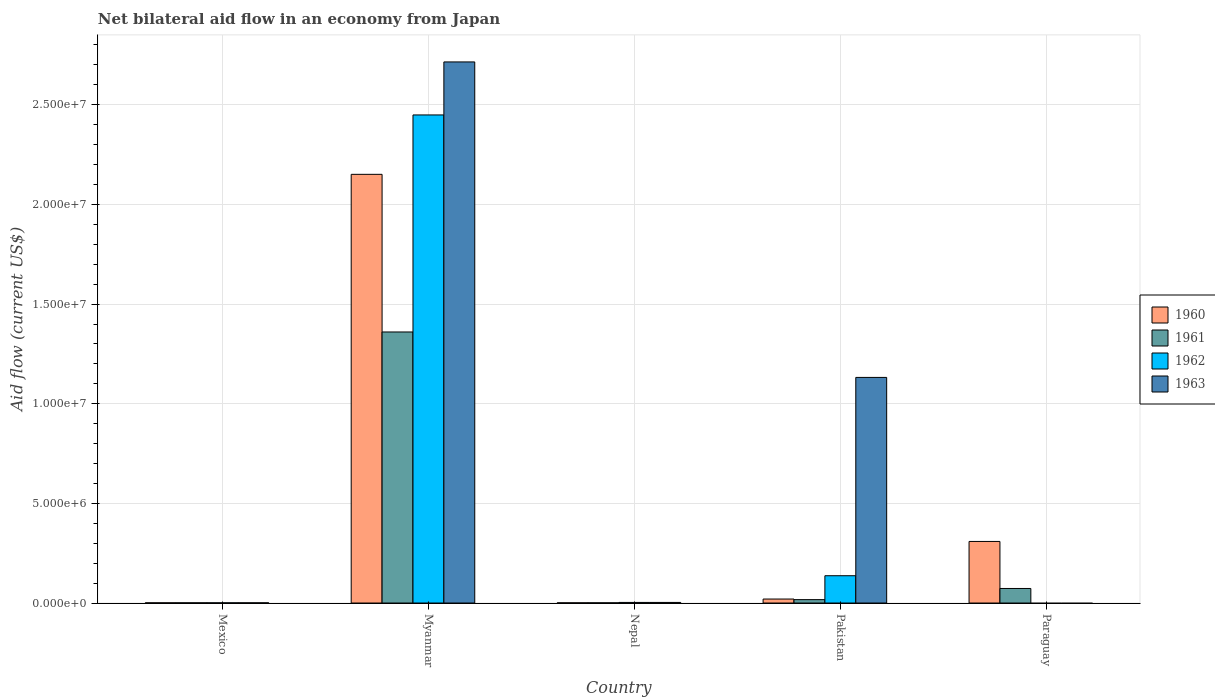How many groups of bars are there?
Your answer should be very brief. 5. How many bars are there on the 5th tick from the right?
Keep it short and to the point. 4. What is the label of the 5th group of bars from the left?
Your response must be concise. Paraguay. Across all countries, what is the maximum net bilateral aid flow in 1961?
Offer a very short reply. 1.36e+07. In which country was the net bilateral aid flow in 1962 maximum?
Keep it short and to the point. Myanmar. What is the total net bilateral aid flow in 1960 in the graph?
Your answer should be very brief. 2.48e+07. What is the difference between the net bilateral aid flow in 1960 in Myanmar and that in Paraguay?
Provide a succinct answer. 1.84e+07. What is the difference between the net bilateral aid flow in 1961 in Myanmar and the net bilateral aid flow in 1963 in Nepal?
Offer a very short reply. 1.36e+07. What is the average net bilateral aid flow in 1961 per country?
Make the answer very short. 2.90e+06. What is the difference between the net bilateral aid flow of/in 1963 and net bilateral aid flow of/in 1961 in Myanmar?
Give a very brief answer. 1.36e+07. In how many countries, is the net bilateral aid flow in 1962 greater than 16000000 US$?
Provide a succinct answer. 1. What is the ratio of the net bilateral aid flow in 1962 in Myanmar to that in Nepal?
Offer a terse response. 816.33. Is the net bilateral aid flow in 1963 in Mexico less than that in Pakistan?
Make the answer very short. Yes. What is the difference between the highest and the second highest net bilateral aid flow in 1962?
Your answer should be compact. 2.45e+07. What is the difference between the highest and the lowest net bilateral aid flow in 1962?
Ensure brevity in your answer.  2.45e+07. How many bars are there?
Keep it short and to the point. 18. Are all the bars in the graph horizontal?
Offer a terse response. No. How many countries are there in the graph?
Offer a very short reply. 5. Are the values on the major ticks of Y-axis written in scientific E-notation?
Offer a terse response. Yes. Does the graph contain any zero values?
Your response must be concise. Yes. Where does the legend appear in the graph?
Your answer should be compact. Center right. What is the title of the graph?
Give a very brief answer. Net bilateral aid flow in an economy from Japan. Does "1995" appear as one of the legend labels in the graph?
Your answer should be very brief. No. What is the Aid flow (current US$) of 1962 in Mexico?
Offer a terse response. 10000. What is the Aid flow (current US$) in 1960 in Myanmar?
Your answer should be compact. 2.15e+07. What is the Aid flow (current US$) of 1961 in Myanmar?
Provide a short and direct response. 1.36e+07. What is the Aid flow (current US$) in 1962 in Myanmar?
Your answer should be compact. 2.45e+07. What is the Aid flow (current US$) of 1963 in Myanmar?
Your answer should be very brief. 2.72e+07. What is the Aid flow (current US$) of 1961 in Nepal?
Provide a succinct answer. 10000. What is the Aid flow (current US$) of 1962 in Pakistan?
Your answer should be very brief. 1.37e+06. What is the Aid flow (current US$) in 1963 in Pakistan?
Offer a terse response. 1.13e+07. What is the Aid flow (current US$) in 1960 in Paraguay?
Offer a terse response. 3.09e+06. What is the Aid flow (current US$) of 1961 in Paraguay?
Give a very brief answer. 7.30e+05. What is the Aid flow (current US$) of 1962 in Paraguay?
Make the answer very short. 0. What is the Aid flow (current US$) of 1963 in Paraguay?
Your answer should be compact. 0. Across all countries, what is the maximum Aid flow (current US$) of 1960?
Your answer should be very brief. 2.15e+07. Across all countries, what is the maximum Aid flow (current US$) of 1961?
Keep it short and to the point. 1.36e+07. Across all countries, what is the maximum Aid flow (current US$) of 1962?
Provide a short and direct response. 2.45e+07. Across all countries, what is the maximum Aid flow (current US$) in 1963?
Offer a terse response. 2.72e+07. What is the total Aid flow (current US$) of 1960 in the graph?
Your answer should be very brief. 2.48e+07. What is the total Aid flow (current US$) in 1961 in the graph?
Offer a very short reply. 1.45e+07. What is the total Aid flow (current US$) in 1962 in the graph?
Provide a succinct answer. 2.59e+07. What is the total Aid flow (current US$) in 1963 in the graph?
Provide a succinct answer. 3.85e+07. What is the difference between the Aid flow (current US$) in 1960 in Mexico and that in Myanmar?
Offer a very short reply. -2.15e+07. What is the difference between the Aid flow (current US$) in 1961 in Mexico and that in Myanmar?
Your answer should be compact. -1.36e+07. What is the difference between the Aid flow (current US$) in 1962 in Mexico and that in Myanmar?
Give a very brief answer. -2.45e+07. What is the difference between the Aid flow (current US$) in 1963 in Mexico and that in Myanmar?
Your response must be concise. -2.71e+07. What is the difference between the Aid flow (current US$) in 1960 in Mexico and that in Pakistan?
Your response must be concise. -1.90e+05. What is the difference between the Aid flow (current US$) of 1961 in Mexico and that in Pakistan?
Your answer should be compact. -1.60e+05. What is the difference between the Aid flow (current US$) in 1962 in Mexico and that in Pakistan?
Provide a short and direct response. -1.36e+06. What is the difference between the Aid flow (current US$) in 1963 in Mexico and that in Pakistan?
Your response must be concise. -1.13e+07. What is the difference between the Aid flow (current US$) in 1960 in Mexico and that in Paraguay?
Offer a very short reply. -3.08e+06. What is the difference between the Aid flow (current US$) of 1961 in Mexico and that in Paraguay?
Keep it short and to the point. -7.20e+05. What is the difference between the Aid flow (current US$) in 1960 in Myanmar and that in Nepal?
Your answer should be very brief. 2.15e+07. What is the difference between the Aid flow (current US$) of 1961 in Myanmar and that in Nepal?
Keep it short and to the point. 1.36e+07. What is the difference between the Aid flow (current US$) in 1962 in Myanmar and that in Nepal?
Keep it short and to the point. 2.45e+07. What is the difference between the Aid flow (current US$) of 1963 in Myanmar and that in Nepal?
Give a very brief answer. 2.71e+07. What is the difference between the Aid flow (current US$) in 1960 in Myanmar and that in Pakistan?
Keep it short and to the point. 2.13e+07. What is the difference between the Aid flow (current US$) in 1961 in Myanmar and that in Pakistan?
Keep it short and to the point. 1.34e+07. What is the difference between the Aid flow (current US$) of 1962 in Myanmar and that in Pakistan?
Provide a succinct answer. 2.31e+07. What is the difference between the Aid flow (current US$) in 1963 in Myanmar and that in Pakistan?
Keep it short and to the point. 1.58e+07. What is the difference between the Aid flow (current US$) in 1960 in Myanmar and that in Paraguay?
Offer a very short reply. 1.84e+07. What is the difference between the Aid flow (current US$) of 1961 in Myanmar and that in Paraguay?
Your response must be concise. 1.29e+07. What is the difference between the Aid flow (current US$) in 1962 in Nepal and that in Pakistan?
Your response must be concise. -1.34e+06. What is the difference between the Aid flow (current US$) in 1963 in Nepal and that in Pakistan?
Offer a very short reply. -1.13e+07. What is the difference between the Aid flow (current US$) in 1960 in Nepal and that in Paraguay?
Keep it short and to the point. -3.08e+06. What is the difference between the Aid flow (current US$) in 1961 in Nepal and that in Paraguay?
Give a very brief answer. -7.20e+05. What is the difference between the Aid flow (current US$) of 1960 in Pakistan and that in Paraguay?
Give a very brief answer. -2.89e+06. What is the difference between the Aid flow (current US$) in 1961 in Pakistan and that in Paraguay?
Offer a terse response. -5.60e+05. What is the difference between the Aid flow (current US$) in 1960 in Mexico and the Aid flow (current US$) in 1961 in Myanmar?
Your answer should be very brief. -1.36e+07. What is the difference between the Aid flow (current US$) of 1960 in Mexico and the Aid flow (current US$) of 1962 in Myanmar?
Make the answer very short. -2.45e+07. What is the difference between the Aid flow (current US$) of 1960 in Mexico and the Aid flow (current US$) of 1963 in Myanmar?
Your answer should be very brief. -2.71e+07. What is the difference between the Aid flow (current US$) of 1961 in Mexico and the Aid flow (current US$) of 1962 in Myanmar?
Your answer should be very brief. -2.45e+07. What is the difference between the Aid flow (current US$) of 1961 in Mexico and the Aid flow (current US$) of 1963 in Myanmar?
Provide a short and direct response. -2.71e+07. What is the difference between the Aid flow (current US$) in 1962 in Mexico and the Aid flow (current US$) in 1963 in Myanmar?
Provide a succinct answer. -2.71e+07. What is the difference between the Aid flow (current US$) in 1960 in Mexico and the Aid flow (current US$) in 1961 in Nepal?
Keep it short and to the point. 0. What is the difference between the Aid flow (current US$) in 1960 in Mexico and the Aid flow (current US$) in 1962 in Nepal?
Offer a very short reply. -2.00e+04. What is the difference between the Aid flow (current US$) of 1961 in Mexico and the Aid flow (current US$) of 1962 in Nepal?
Provide a succinct answer. -2.00e+04. What is the difference between the Aid flow (current US$) of 1962 in Mexico and the Aid flow (current US$) of 1963 in Nepal?
Provide a succinct answer. -2.00e+04. What is the difference between the Aid flow (current US$) of 1960 in Mexico and the Aid flow (current US$) of 1961 in Pakistan?
Provide a succinct answer. -1.60e+05. What is the difference between the Aid flow (current US$) in 1960 in Mexico and the Aid flow (current US$) in 1962 in Pakistan?
Provide a succinct answer. -1.36e+06. What is the difference between the Aid flow (current US$) of 1960 in Mexico and the Aid flow (current US$) of 1963 in Pakistan?
Provide a succinct answer. -1.13e+07. What is the difference between the Aid flow (current US$) in 1961 in Mexico and the Aid flow (current US$) in 1962 in Pakistan?
Ensure brevity in your answer.  -1.36e+06. What is the difference between the Aid flow (current US$) in 1961 in Mexico and the Aid flow (current US$) in 1963 in Pakistan?
Provide a succinct answer. -1.13e+07. What is the difference between the Aid flow (current US$) of 1962 in Mexico and the Aid flow (current US$) of 1963 in Pakistan?
Your answer should be compact. -1.13e+07. What is the difference between the Aid flow (current US$) of 1960 in Mexico and the Aid flow (current US$) of 1961 in Paraguay?
Keep it short and to the point. -7.20e+05. What is the difference between the Aid flow (current US$) in 1960 in Myanmar and the Aid flow (current US$) in 1961 in Nepal?
Your answer should be very brief. 2.15e+07. What is the difference between the Aid flow (current US$) of 1960 in Myanmar and the Aid flow (current US$) of 1962 in Nepal?
Your answer should be compact. 2.15e+07. What is the difference between the Aid flow (current US$) in 1960 in Myanmar and the Aid flow (current US$) in 1963 in Nepal?
Your answer should be very brief. 2.15e+07. What is the difference between the Aid flow (current US$) of 1961 in Myanmar and the Aid flow (current US$) of 1962 in Nepal?
Your answer should be compact. 1.36e+07. What is the difference between the Aid flow (current US$) in 1961 in Myanmar and the Aid flow (current US$) in 1963 in Nepal?
Offer a very short reply. 1.36e+07. What is the difference between the Aid flow (current US$) in 1962 in Myanmar and the Aid flow (current US$) in 1963 in Nepal?
Ensure brevity in your answer.  2.45e+07. What is the difference between the Aid flow (current US$) of 1960 in Myanmar and the Aid flow (current US$) of 1961 in Pakistan?
Your answer should be very brief. 2.13e+07. What is the difference between the Aid flow (current US$) of 1960 in Myanmar and the Aid flow (current US$) of 1962 in Pakistan?
Give a very brief answer. 2.01e+07. What is the difference between the Aid flow (current US$) in 1960 in Myanmar and the Aid flow (current US$) in 1963 in Pakistan?
Provide a short and direct response. 1.02e+07. What is the difference between the Aid flow (current US$) of 1961 in Myanmar and the Aid flow (current US$) of 1962 in Pakistan?
Your answer should be very brief. 1.22e+07. What is the difference between the Aid flow (current US$) in 1961 in Myanmar and the Aid flow (current US$) in 1963 in Pakistan?
Offer a terse response. 2.28e+06. What is the difference between the Aid flow (current US$) in 1962 in Myanmar and the Aid flow (current US$) in 1963 in Pakistan?
Your answer should be very brief. 1.32e+07. What is the difference between the Aid flow (current US$) in 1960 in Myanmar and the Aid flow (current US$) in 1961 in Paraguay?
Offer a very short reply. 2.08e+07. What is the difference between the Aid flow (current US$) of 1960 in Nepal and the Aid flow (current US$) of 1962 in Pakistan?
Your answer should be very brief. -1.36e+06. What is the difference between the Aid flow (current US$) of 1960 in Nepal and the Aid flow (current US$) of 1963 in Pakistan?
Provide a succinct answer. -1.13e+07. What is the difference between the Aid flow (current US$) of 1961 in Nepal and the Aid flow (current US$) of 1962 in Pakistan?
Provide a short and direct response. -1.36e+06. What is the difference between the Aid flow (current US$) in 1961 in Nepal and the Aid flow (current US$) in 1963 in Pakistan?
Offer a very short reply. -1.13e+07. What is the difference between the Aid flow (current US$) of 1962 in Nepal and the Aid flow (current US$) of 1963 in Pakistan?
Provide a short and direct response. -1.13e+07. What is the difference between the Aid flow (current US$) in 1960 in Nepal and the Aid flow (current US$) in 1961 in Paraguay?
Provide a short and direct response. -7.20e+05. What is the difference between the Aid flow (current US$) of 1960 in Pakistan and the Aid flow (current US$) of 1961 in Paraguay?
Ensure brevity in your answer.  -5.30e+05. What is the average Aid flow (current US$) of 1960 per country?
Provide a succinct answer. 4.96e+06. What is the average Aid flow (current US$) in 1961 per country?
Provide a short and direct response. 2.90e+06. What is the average Aid flow (current US$) in 1962 per country?
Provide a short and direct response. 5.18e+06. What is the average Aid flow (current US$) of 1963 per country?
Ensure brevity in your answer.  7.70e+06. What is the difference between the Aid flow (current US$) in 1960 and Aid flow (current US$) in 1961 in Mexico?
Offer a very short reply. 0. What is the difference between the Aid flow (current US$) in 1960 and Aid flow (current US$) in 1962 in Mexico?
Provide a succinct answer. 0. What is the difference between the Aid flow (current US$) in 1960 and Aid flow (current US$) in 1963 in Mexico?
Your answer should be very brief. 0. What is the difference between the Aid flow (current US$) in 1960 and Aid flow (current US$) in 1961 in Myanmar?
Your answer should be compact. 7.91e+06. What is the difference between the Aid flow (current US$) in 1960 and Aid flow (current US$) in 1962 in Myanmar?
Your response must be concise. -2.98e+06. What is the difference between the Aid flow (current US$) of 1960 and Aid flow (current US$) of 1963 in Myanmar?
Keep it short and to the point. -5.64e+06. What is the difference between the Aid flow (current US$) of 1961 and Aid flow (current US$) of 1962 in Myanmar?
Offer a very short reply. -1.09e+07. What is the difference between the Aid flow (current US$) of 1961 and Aid flow (current US$) of 1963 in Myanmar?
Offer a very short reply. -1.36e+07. What is the difference between the Aid flow (current US$) in 1962 and Aid flow (current US$) in 1963 in Myanmar?
Provide a short and direct response. -2.66e+06. What is the difference between the Aid flow (current US$) in 1960 and Aid flow (current US$) in 1963 in Nepal?
Offer a very short reply. -2.00e+04. What is the difference between the Aid flow (current US$) in 1961 and Aid flow (current US$) in 1963 in Nepal?
Your answer should be very brief. -2.00e+04. What is the difference between the Aid flow (current US$) of 1962 and Aid flow (current US$) of 1963 in Nepal?
Keep it short and to the point. 0. What is the difference between the Aid flow (current US$) in 1960 and Aid flow (current US$) in 1961 in Pakistan?
Your response must be concise. 3.00e+04. What is the difference between the Aid flow (current US$) of 1960 and Aid flow (current US$) of 1962 in Pakistan?
Your answer should be very brief. -1.17e+06. What is the difference between the Aid flow (current US$) in 1960 and Aid flow (current US$) in 1963 in Pakistan?
Offer a very short reply. -1.11e+07. What is the difference between the Aid flow (current US$) of 1961 and Aid flow (current US$) of 1962 in Pakistan?
Your answer should be very brief. -1.20e+06. What is the difference between the Aid flow (current US$) in 1961 and Aid flow (current US$) in 1963 in Pakistan?
Give a very brief answer. -1.12e+07. What is the difference between the Aid flow (current US$) of 1962 and Aid flow (current US$) of 1963 in Pakistan?
Offer a terse response. -9.95e+06. What is the difference between the Aid flow (current US$) in 1960 and Aid flow (current US$) in 1961 in Paraguay?
Offer a terse response. 2.36e+06. What is the ratio of the Aid flow (current US$) in 1960 in Mexico to that in Myanmar?
Ensure brevity in your answer.  0. What is the ratio of the Aid flow (current US$) of 1961 in Mexico to that in Myanmar?
Provide a succinct answer. 0. What is the ratio of the Aid flow (current US$) of 1963 in Mexico to that in Nepal?
Ensure brevity in your answer.  0.33. What is the ratio of the Aid flow (current US$) of 1961 in Mexico to that in Pakistan?
Your response must be concise. 0.06. What is the ratio of the Aid flow (current US$) in 1962 in Mexico to that in Pakistan?
Make the answer very short. 0.01. What is the ratio of the Aid flow (current US$) in 1963 in Mexico to that in Pakistan?
Your answer should be compact. 0. What is the ratio of the Aid flow (current US$) of 1960 in Mexico to that in Paraguay?
Offer a very short reply. 0. What is the ratio of the Aid flow (current US$) in 1961 in Mexico to that in Paraguay?
Offer a terse response. 0.01. What is the ratio of the Aid flow (current US$) of 1960 in Myanmar to that in Nepal?
Offer a terse response. 2151. What is the ratio of the Aid flow (current US$) of 1961 in Myanmar to that in Nepal?
Offer a terse response. 1360. What is the ratio of the Aid flow (current US$) of 1962 in Myanmar to that in Nepal?
Give a very brief answer. 816.33. What is the ratio of the Aid flow (current US$) in 1963 in Myanmar to that in Nepal?
Make the answer very short. 905. What is the ratio of the Aid flow (current US$) of 1960 in Myanmar to that in Pakistan?
Offer a very short reply. 107.55. What is the ratio of the Aid flow (current US$) of 1962 in Myanmar to that in Pakistan?
Keep it short and to the point. 17.88. What is the ratio of the Aid flow (current US$) of 1963 in Myanmar to that in Pakistan?
Provide a succinct answer. 2.4. What is the ratio of the Aid flow (current US$) of 1960 in Myanmar to that in Paraguay?
Offer a very short reply. 6.96. What is the ratio of the Aid flow (current US$) of 1961 in Myanmar to that in Paraguay?
Your answer should be compact. 18.63. What is the ratio of the Aid flow (current US$) in 1960 in Nepal to that in Pakistan?
Your answer should be very brief. 0.05. What is the ratio of the Aid flow (current US$) in 1961 in Nepal to that in Pakistan?
Ensure brevity in your answer.  0.06. What is the ratio of the Aid flow (current US$) in 1962 in Nepal to that in Pakistan?
Your answer should be compact. 0.02. What is the ratio of the Aid flow (current US$) in 1963 in Nepal to that in Pakistan?
Provide a succinct answer. 0. What is the ratio of the Aid flow (current US$) in 1960 in Nepal to that in Paraguay?
Make the answer very short. 0. What is the ratio of the Aid flow (current US$) of 1961 in Nepal to that in Paraguay?
Make the answer very short. 0.01. What is the ratio of the Aid flow (current US$) of 1960 in Pakistan to that in Paraguay?
Give a very brief answer. 0.06. What is the ratio of the Aid flow (current US$) in 1961 in Pakistan to that in Paraguay?
Your answer should be very brief. 0.23. What is the difference between the highest and the second highest Aid flow (current US$) in 1960?
Provide a short and direct response. 1.84e+07. What is the difference between the highest and the second highest Aid flow (current US$) in 1961?
Your answer should be compact. 1.29e+07. What is the difference between the highest and the second highest Aid flow (current US$) of 1962?
Ensure brevity in your answer.  2.31e+07. What is the difference between the highest and the second highest Aid flow (current US$) in 1963?
Make the answer very short. 1.58e+07. What is the difference between the highest and the lowest Aid flow (current US$) in 1960?
Provide a succinct answer. 2.15e+07. What is the difference between the highest and the lowest Aid flow (current US$) of 1961?
Provide a short and direct response. 1.36e+07. What is the difference between the highest and the lowest Aid flow (current US$) of 1962?
Keep it short and to the point. 2.45e+07. What is the difference between the highest and the lowest Aid flow (current US$) in 1963?
Ensure brevity in your answer.  2.72e+07. 